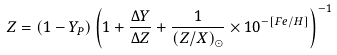<formula> <loc_0><loc_0><loc_500><loc_500>Z = ( 1 - Y _ { P } ) \left ( 1 + \frac { \Delta Y } { \Delta Z } + \frac { 1 } { ( Z / X ) _ { \odot } } \times 1 0 ^ { - [ F e / H ] } \right ) ^ { - 1 }</formula> 